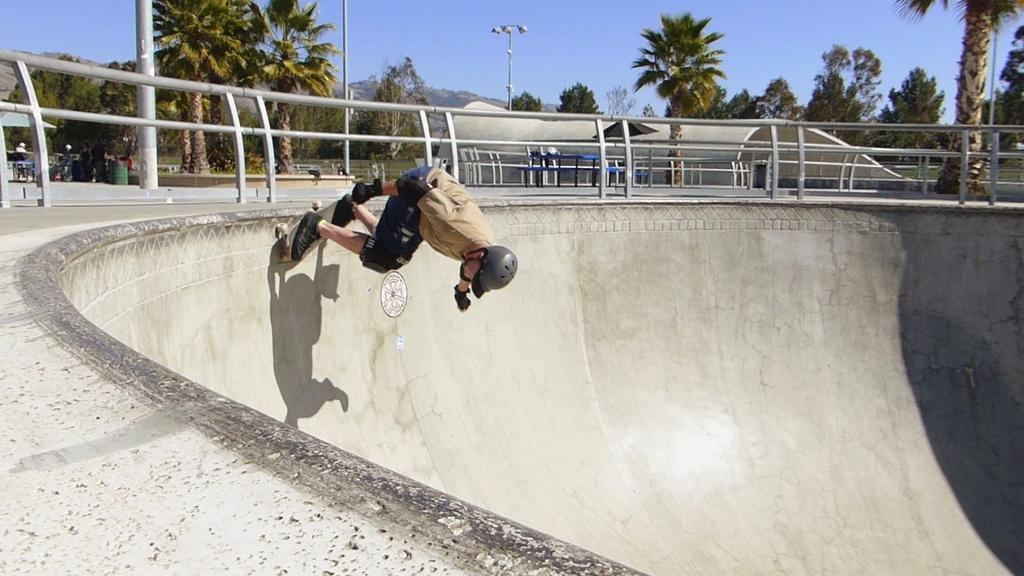Could you give a brief overview of what you see in this image? As we can see in the image there is a person wearing helmet and skating. In the background there are trees, bench, streetlamp, group of people and at the top there is sky. 